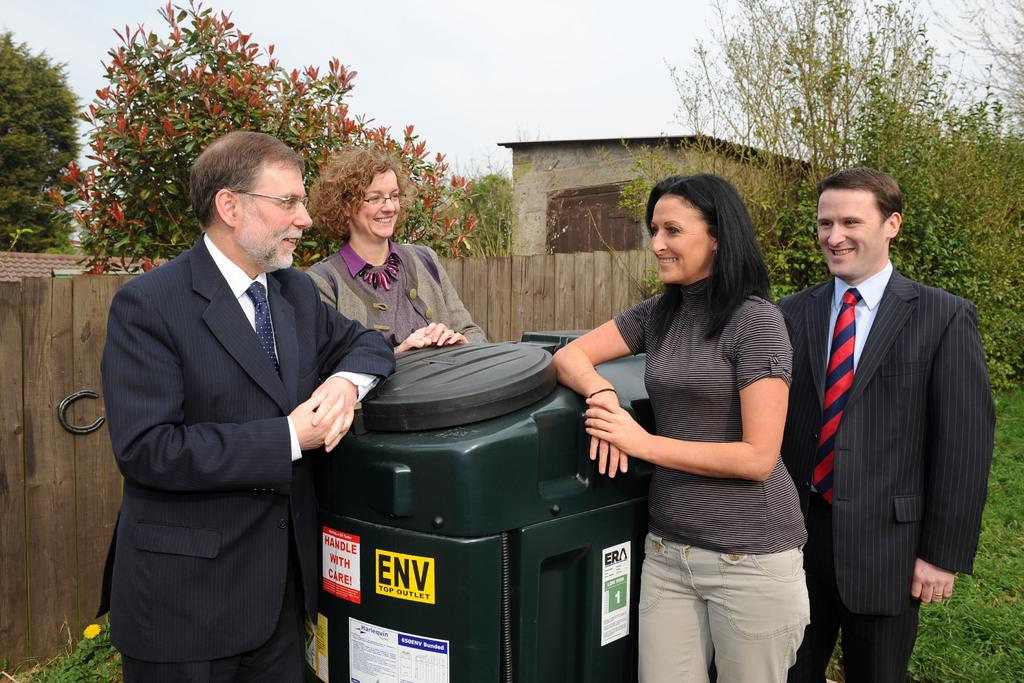<image>
Describe the image concisely. Four people stand against a trash can that reads ENV on the front 